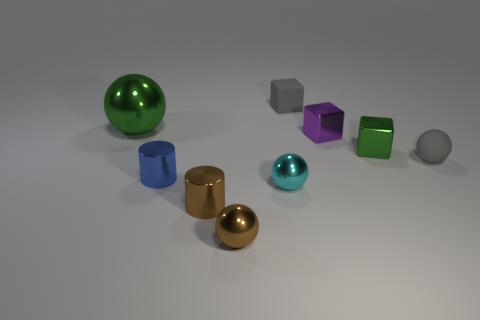Subtract all small matte cubes. How many cubes are left? 2 Subtract 1 blocks. How many blocks are left? 2 Subtract all cyan spheres. How many spheres are left? 3 Add 1 large cyan metal spheres. How many objects exist? 10 Subtract all yellow balls. Subtract all green cylinders. How many balls are left? 4 Subtract all cubes. How many objects are left? 6 Add 7 gray blocks. How many gray blocks exist? 8 Subtract 0 yellow spheres. How many objects are left? 9 Subtract all green metallic objects. Subtract all brown cylinders. How many objects are left? 6 Add 8 metallic cylinders. How many metallic cylinders are left? 10 